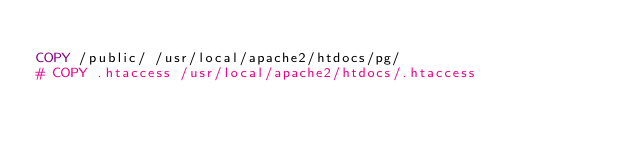<code> <loc_0><loc_0><loc_500><loc_500><_Dockerfile_>
COPY /public/ /usr/local/apache2/htdocs/pg/
# COPY .htaccess /usr/local/apache2/htdocs/.htaccess
</code> 